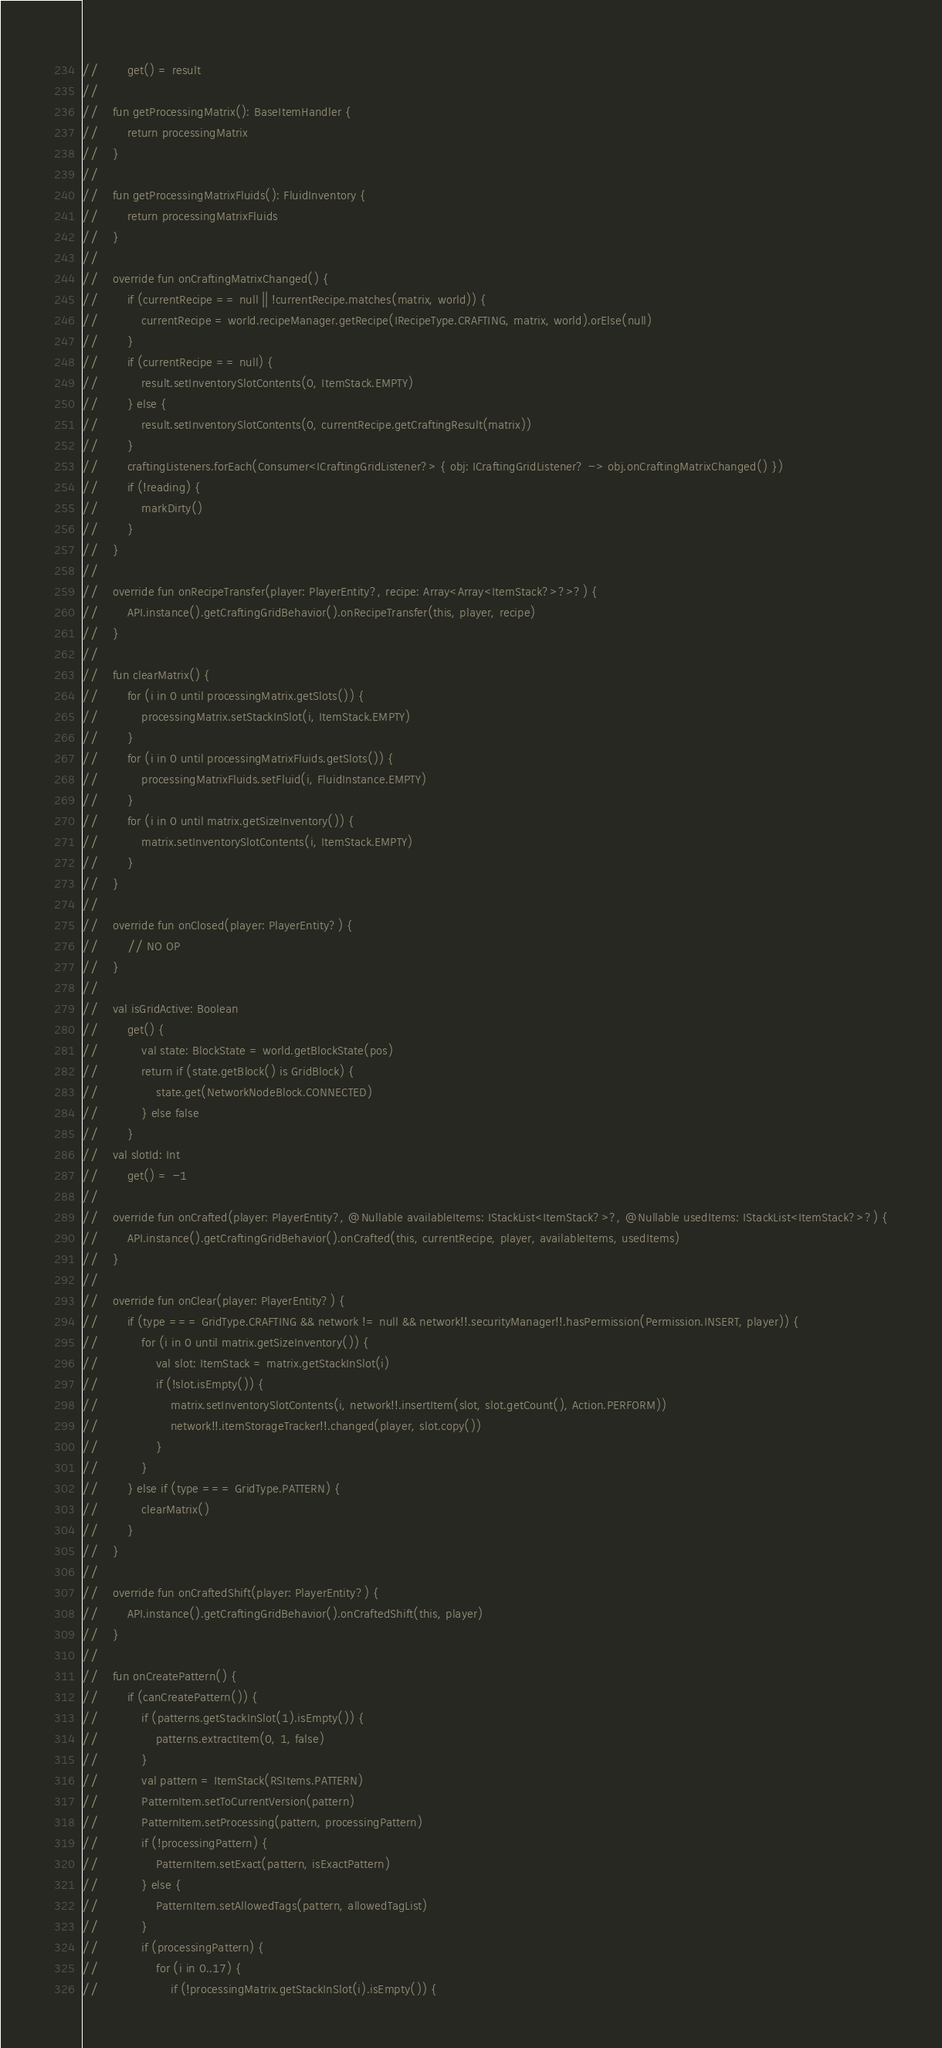<code> <loc_0><loc_0><loc_500><loc_500><_Kotlin_>//        get() = result
//
//    fun getProcessingMatrix(): BaseItemHandler {
//        return processingMatrix
//    }
//
//    fun getProcessingMatrixFluids(): FluidInventory {
//        return processingMatrixFluids
//    }
//
//    override fun onCraftingMatrixChanged() {
//        if (currentRecipe == null || !currentRecipe.matches(matrix, world)) {
//            currentRecipe = world.recipeManager.getRecipe(IRecipeType.CRAFTING, matrix, world).orElse(null)
//        }
//        if (currentRecipe == null) {
//            result.setInventorySlotContents(0, ItemStack.EMPTY)
//        } else {
//            result.setInventorySlotContents(0, currentRecipe.getCraftingResult(matrix))
//        }
//        craftingListeners.forEach(Consumer<ICraftingGridListener?> { obj: ICraftingGridListener? -> obj.onCraftingMatrixChanged() })
//        if (!reading) {
//            markDirty()
//        }
//    }
//
//    override fun onRecipeTransfer(player: PlayerEntity?, recipe: Array<Array<ItemStack?>?>?) {
//        API.instance().getCraftingGridBehavior().onRecipeTransfer(this, player, recipe)
//    }
//
//    fun clearMatrix() {
//        for (i in 0 until processingMatrix.getSlots()) {
//            processingMatrix.setStackInSlot(i, ItemStack.EMPTY)
//        }
//        for (i in 0 until processingMatrixFluids.getSlots()) {
//            processingMatrixFluids.setFluid(i, FluidInstance.EMPTY)
//        }
//        for (i in 0 until matrix.getSizeInventory()) {
//            matrix.setInventorySlotContents(i, ItemStack.EMPTY)
//        }
//    }
//
//    override fun onClosed(player: PlayerEntity?) {
//        // NO OP
//    }
//
//    val isGridActive: Boolean
//        get() {
//            val state: BlockState = world.getBlockState(pos)
//            return if (state.getBlock() is GridBlock) {
//                state.get(NetworkNodeBlock.CONNECTED)
//            } else false
//        }
//    val slotId: Int
//        get() = -1
//
//    override fun onCrafted(player: PlayerEntity?, @Nullable availableItems: IStackList<ItemStack?>?, @Nullable usedItems: IStackList<ItemStack?>?) {
//        API.instance().getCraftingGridBehavior().onCrafted(this, currentRecipe, player, availableItems, usedItems)
//    }
//
//    override fun onClear(player: PlayerEntity?) {
//        if (type === GridType.CRAFTING && network != null && network!!.securityManager!!.hasPermission(Permission.INSERT, player)) {
//            for (i in 0 until matrix.getSizeInventory()) {
//                val slot: ItemStack = matrix.getStackInSlot(i)
//                if (!slot.isEmpty()) {
//                    matrix.setInventorySlotContents(i, network!!.insertItem(slot, slot.getCount(), Action.PERFORM))
//                    network!!.itemStorageTracker!!.changed(player, slot.copy())
//                }
//            }
//        } else if (type === GridType.PATTERN) {
//            clearMatrix()
//        }
//    }
//
//    override fun onCraftedShift(player: PlayerEntity?) {
//        API.instance().getCraftingGridBehavior().onCraftedShift(this, player)
//    }
//
//    fun onCreatePattern() {
//        if (canCreatePattern()) {
//            if (patterns.getStackInSlot(1).isEmpty()) {
//                patterns.extractItem(0, 1, false)
//            }
//            val pattern = ItemStack(RSItems.PATTERN)
//            PatternItem.setToCurrentVersion(pattern)
//            PatternItem.setProcessing(pattern, processingPattern)
//            if (!processingPattern) {
//                PatternItem.setExact(pattern, isExactPattern)
//            } else {
//                PatternItem.setAllowedTags(pattern, allowedTagList)
//            }
//            if (processingPattern) {
//                for (i in 0..17) {
//                    if (!processingMatrix.getStackInSlot(i).isEmpty()) {</code> 